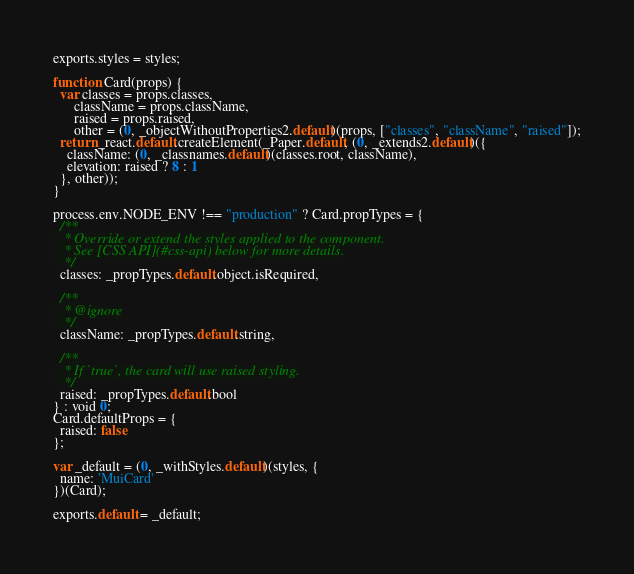Convert code to text. <code><loc_0><loc_0><loc_500><loc_500><_JavaScript_>exports.styles = styles;

function Card(props) {
  var classes = props.classes,
      className = props.className,
      raised = props.raised,
      other = (0, _objectWithoutProperties2.default)(props, ["classes", "className", "raised"]);
  return _react.default.createElement(_Paper.default, (0, _extends2.default)({
    className: (0, _classnames.default)(classes.root, className),
    elevation: raised ? 8 : 1
  }, other));
}

process.env.NODE_ENV !== "production" ? Card.propTypes = {
  /**
   * Override or extend the styles applied to the component.
   * See [CSS API](#css-api) below for more details.
   */
  classes: _propTypes.default.object.isRequired,

  /**
   * @ignore
   */
  className: _propTypes.default.string,

  /**
   * If `true`, the card will use raised styling.
   */
  raised: _propTypes.default.bool
} : void 0;
Card.defaultProps = {
  raised: false
};

var _default = (0, _withStyles.default)(styles, {
  name: 'MuiCard'
})(Card);

exports.default = _default;</code> 